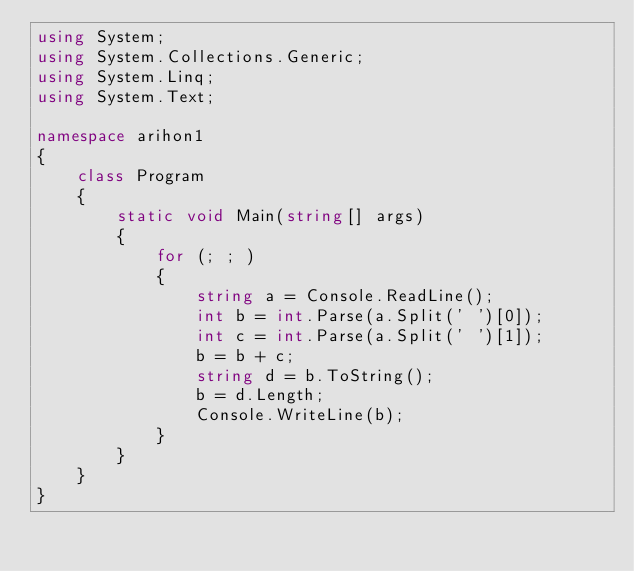Convert code to text. <code><loc_0><loc_0><loc_500><loc_500><_C#_>using System;
using System.Collections.Generic;
using System.Linq;
using System.Text;

namespace arihon1
{
    class Program
    {
        static void Main(string[] args)
        {
            for (; ; )
            {
                string a = Console.ReadLine();
                int b = int.Parse(a.Split(' ')[0]);
                int c = int.Parse(a.Split(' ')[1]);
                b = b + c;
                string d = b.ToString();
                b = d.Length;
                Console.WriteLine(b);
            }
        }
    }
}</code> 